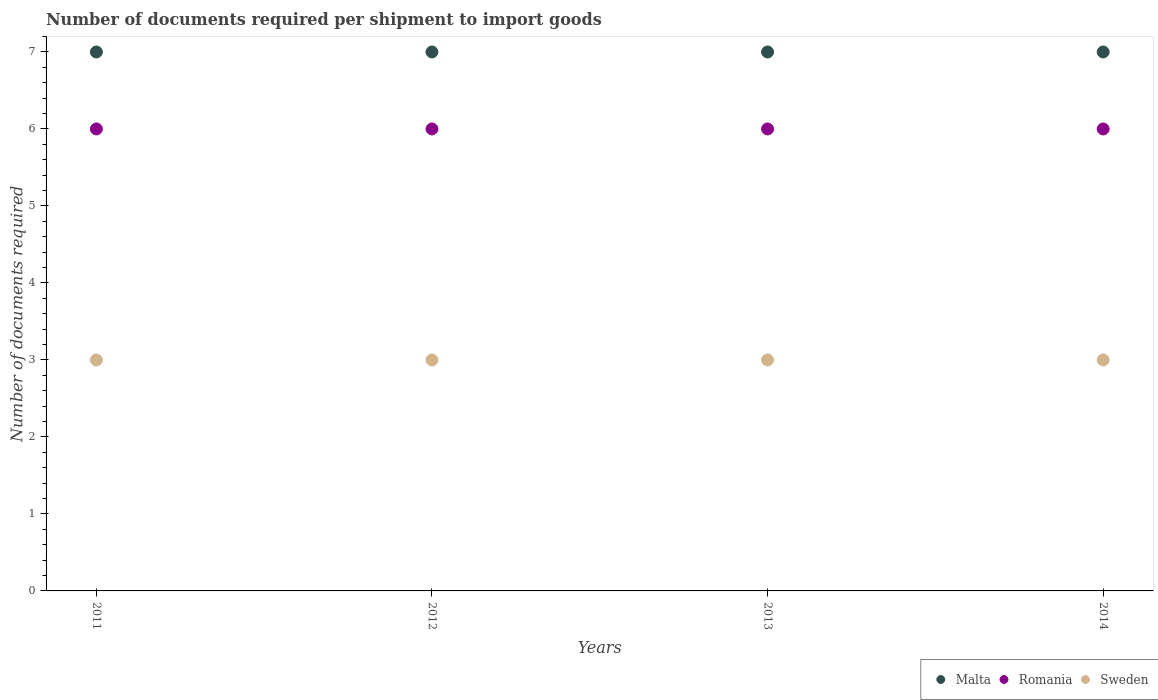Is the number of dotlines equal to the number of legend labels?
Provide a succinct answer. Yes. What is the number of documents required per shipment to import goods in Malta in 2014?
Your answer should be very brief. 7. Across all years, what is the maximum number of documents required per shipment to import goods in Malta?
Keep it short and to the point. 7. Across all years, what is the minimum number of documents required per shipment to import goods in Romania?
Make the answer very short. 6. In which year was the number of documents required per shipment to import goods in Sweden maximum?
Provide a short and direct response. 2011. What is the total number of documents required per shipment to import goods in Malta in the graph?
Your response must be concise. 28. What is the average number of documents required per shipment to import goods in Malta per year?
Ensure brevity in your answer.  7. What is the ratio of the number of documents required per shipment to import goods in Romania in 2012 to that in 2014?
Give a very brief answer. 1. Is the number of documents required per shipment to import goods in Malta in 2011 less than that in 2013?
Ensure brevity in your answer.  No. Is the difference between the number of documents required per shipment to import goods in Malta in 2012 and 2013 greater than the difference between the number of documents required per shipment to import goods in Romania in 2012 and 2013?
Your response must be concise. No. What is the difference between the highest and the second highest number of documents required per shipment to import goods in Malta?
Keep it short and to the point. 0. Is the number of documents required per shipment to import goods in Malta strictly less than the number of documents required per shipment to import goods in Sweden over the years?
Offer a very short reply. No. How many dotlines are there?
Provide a succinct answer. 3. What is the difference between two consecutive major ticks on the Y-axis?
Your answer should be compact. 1. Does the graph contain any zero values?
Provide a short and direct response. No. Does the graph contain grids?
Your response must be concise. No. Where does the legend appear in the graph?
Your answer should be very brief. Bottom right. How many legend labels are there?
Ensure brevity in your answer.  3. How are the legend labels stacked?
Your answer should be very brief. Horizontal. What is the title of the graph?
Your answer should be very brief. Number of documents required per shipment to import goods. What is the label or title of the Y-axis?
Offer a terse response. Number of documents required. What is the Number of documents required of Malta in 2011?
Your response must be concise. 7. What is the Number of documents required in Romania in 2011?
Make the answer very short. 6. What is the Number of documents required in Sweden in 2011?
Your answer should be very brief. 3. What is the Number of documents required of Malta in 2012?
Your answer should be compact. 7. What is the Number of documents required in Sweden in 2012?
Keep it short and to the point. 3. What is the Number of documents required in Malta in 2013?
Your answer should be very brief. 7. What is the Number of documents required of Sweden in 2013?
Ensure brevity in your answer.  3. What is the Number of documents required of Malta in 2014?
Provide a succinct answer. 7. What is the Number of documents required of Romania in 2014?
Make the answer very short. 6. What is the Number of documents required in Sweden in 2014?
Your response must be concise. 3. Across all years, what is the maximum Number of documents required in Sweden?
Your answer should be compact. 3. What is the total Number of documents required of Malta in the graph?
Provide a succinct answer. 28. What is the total Number of documents required in Sweden in the graph?
Provide a succinct answer. 12. What is the difference between the Number of documents required of Malta in 2011 and that in 2012?
Your answer should be compact. 0. What is the difference between the Number of documents required of Romania in 2011 and that in 2012?
Keep it short and to the point. 0. What is the difference between the Number of documents required in Sweden in 2011 and that in 2012?
Provide a succinct answer. 0. What is the difference between the Number of documents required of Sweden in 2011 and that in 2013?
Your response must be concise. 0. What is the difference between the Number of documents required in Sweden in 2011 and that in 2014?
Your answer should be compact. 0. What is the difference between the Number of documents required in Malta in 2012 and that in 2013?
Provide a short and direct response. 0. What is the difference between the Number of documents required in Sweden in 2012 and that in 2013?
Your answer should be compact. 0. What is the difference between the Number of documents required in Malta in 2013 and that in 2014?
Provide a short and direct response. 0. What is the difference between the Number of documents required of Romania in 2013 and that in 2014?
Make the answer very short. 0. What is the difference between the Number of documents required in Sweden in 2013 and that in 2014?
Offer a terse response. 0. What is the difference between the Number of documents required of Malta in 2011 and the Number of documents required of Romania in 2012?
Make the answer very short. 1. What is the difference between the Number of documents required of Malta in 2011 and the Number of documents required of Sweden in 2012?
Ensure brevity in your answer.  4. What is the difference between the Number of documents required in Romania in 2011 and the Number of documents required in Sweden in 2012?
Offer a very short reply. 3. What is the difference between the Number of documents required in Malta in 2011 and the Number of documents required in Sweden in 2013?
Make the answer very short. 4. What is the difference between the Number of documents required in Malta in 2011 and the Number of documents required in Romania in 2014?
Make the answer very short. 1. What is the difference between the Number of documents required of Malta in 2012 and the Number of documents required of Sweden in 2014?
Your response must be concise. 4. What is the difference between the Number of documents required of Romania in 2012 and the Number of documents required of Sweden in 2014?
Give a very brief answer. 3. What is the difference between the Number of documents required in Malta in 2013 and the Number of documents required in Romania in 2014?
Offer a very short reply. 1. What is the average Number of documents required in Malta per year?
Keep it short and to the point. 7. In the year 2011, what is the difference between the Number of documents required of Malta and Number of documents required of Sweden?
Your answer should be compact. 4. In the year 2011, what is the difference between the Number of documents required of Romania and Number of documents required of Sweden?
Your answer should be compact. 3. In the year 2012, what is the difference between the Number of documents required in Malta and Number of documents required in Sweden?
Your answer should be very brief. 4. In the year 2013, what is the difference between the Number of documents required of Malta and Number of documents required of Romania?
Keep it short and to the point. 1. In the year 2013, what is the difference between the Number of documents required of Romania and Number of documents required of Sweden?
Give a very brief answer. 3. In the year 2014, what is the difference between the Number of documents required in Malta and Number of documents required in Romania?
Keep it short and to the point. 1. In the year 2014, what is the difference between the Number of documents required of Romania and Number of documents required of Sweden?
Your response must be concise. 3. What is the ratio of the Number of documents required of Malta in 2011 to that in 2012?
Keep it short and to the point. 1. What is the ratio of the Number of documents required of Sweden in 2011 to that in 2012?
Offer a very short reply. 1. What is the ratio of the Number of documents required in Malta in 2011 to that in 2013?
Provide a succinct answer. 1. What is the ratio of the Number of documents required in Romania in 2011 to that in 2013?
Keep it short and to the point. 1. What is the ratio of the Number of documents required in Romania in 2011 to that in 2014?
Give a very brief answer. 1. What is the ratio of the Number of documents required of Romania in 2012 to that in 2013?
Make the answer very short. 1. What is the ratio of the Number of documents required in Malta in 2012 to that in 2014?
Ensure brevity in your answer.  1. What is the ratio of the Number of documents required in Sweden in 2012 to that in 2014?
Your answer should be very brief. 1. What is the difference between the highest and the second highest Number of documents required in Romania?
Keep it short and to the point. 0. What is the difference between the highest and the second highest Number of documents required in Sweden?
Your answer should be compact. 0. What is the difference between the highest and the lowest Number of documents required of Romania?
Provide a short and direct response. 0. 